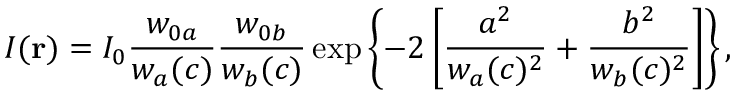Convert formula to latex. <formula><loc_0><loc_0><loc_500><loc_500>I ( r ) = I _ { 0 } \frac { w _ { 0 a } } { w _ { a } ( c ) } \frac { w _ { 0 b } } { w _ { b } ( c ) } \exp \left \{ - 2 \left [ \frac { a ^ { 2 } } { w _ { a } ( c ) ^ { 2 } } + \frac { b ^ { 2 } } { w _ { b } ( c ) ^ { 2 } } \right ] \right \} ,</formula> 